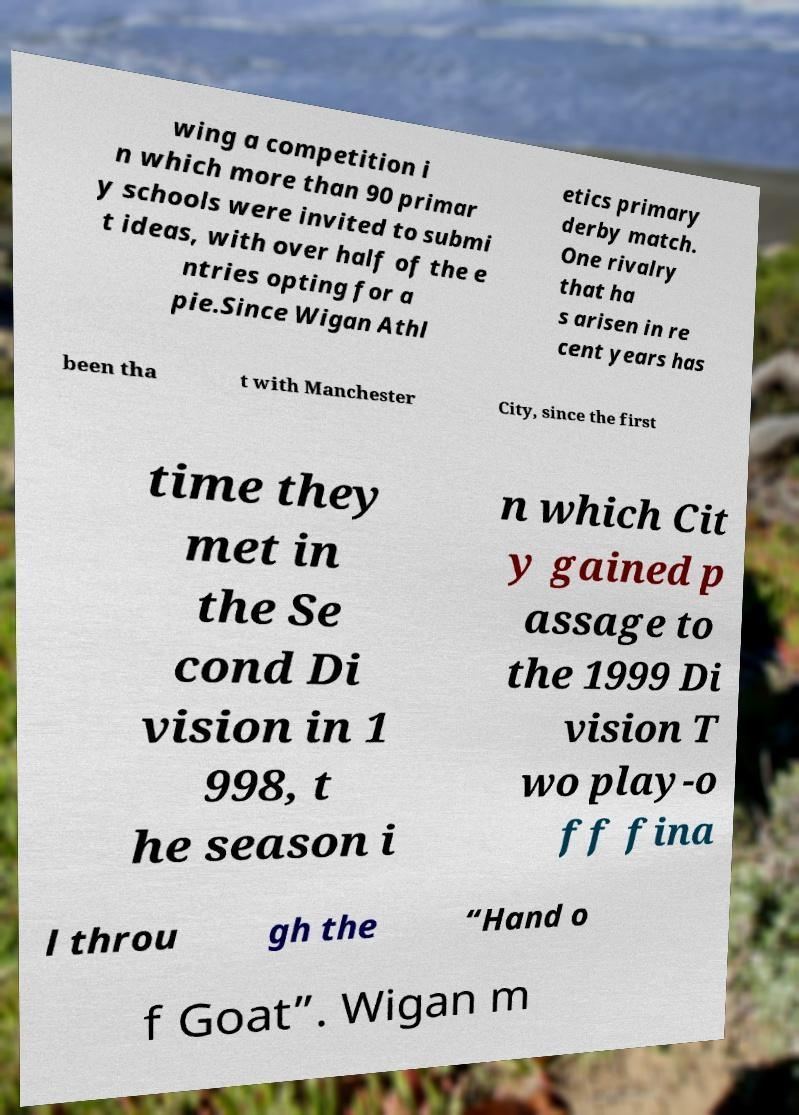There's text embedded in this image that I need extracted. Can you transcribe it verbatim? wing a competition i n which more than 90 primar y schools were invited to submi t ideas, with over half of the e ntries opting for a pie.Since Wigan Athl etics primary derby match. One rivalry that ha s arisen in re cent years has been tha t with Manchester City, since the first time they met in the Se cond Di vision in 1 998, t he season i n which Cit y gained p assage to the 1999 Di vision T wo play-o ff fina l throu gh the “Hand o f Goat”. Wigan m 